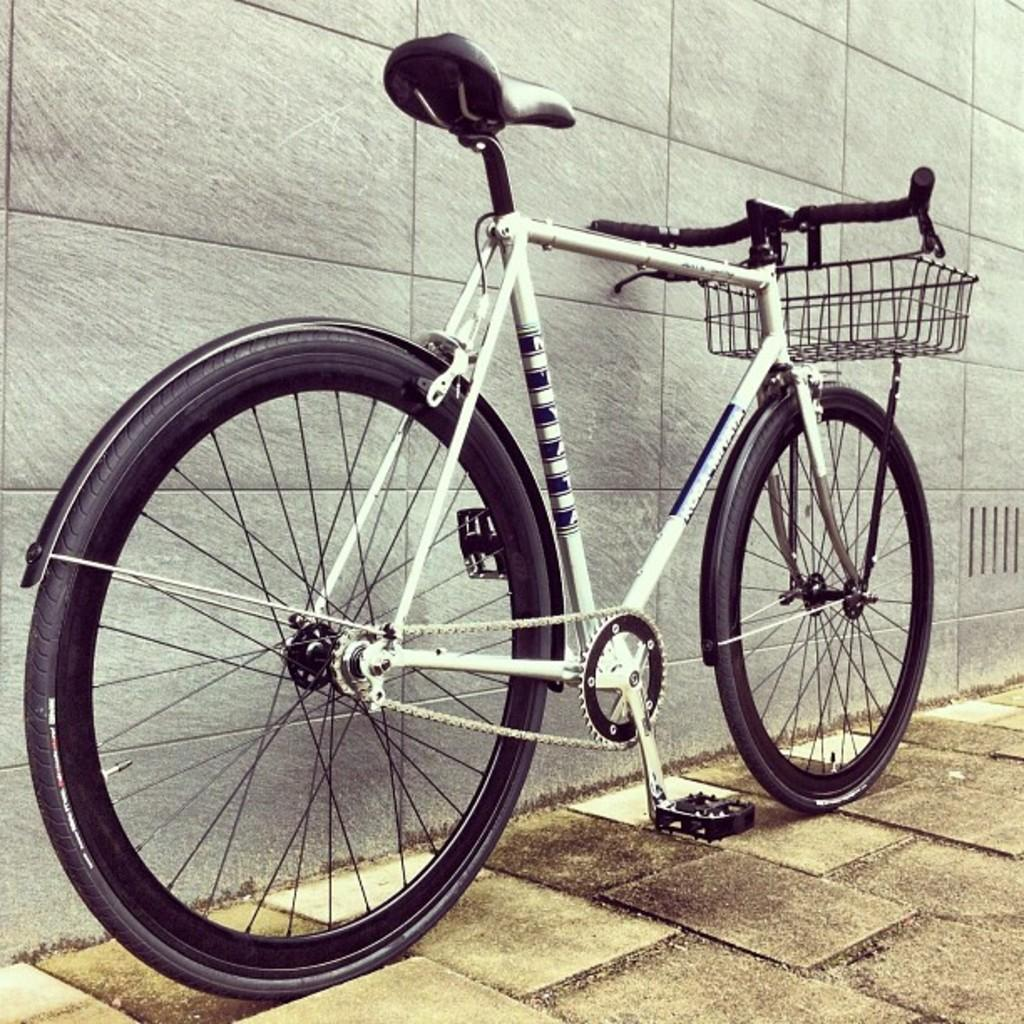What is the main subject of the image? The main subject of the image is a bicycle. Where is the bicycle located in the image? The bicycle is in the middle of the image. What can be seen in the background of the image? There is a wall in the background of the image. What holiday is being celebrated in the image? There is no indication of a holiday being celebrated in the image. What surprise is hidden behind the wall in the image? There is no indication of a surprise hidden behind the wall in the image. 